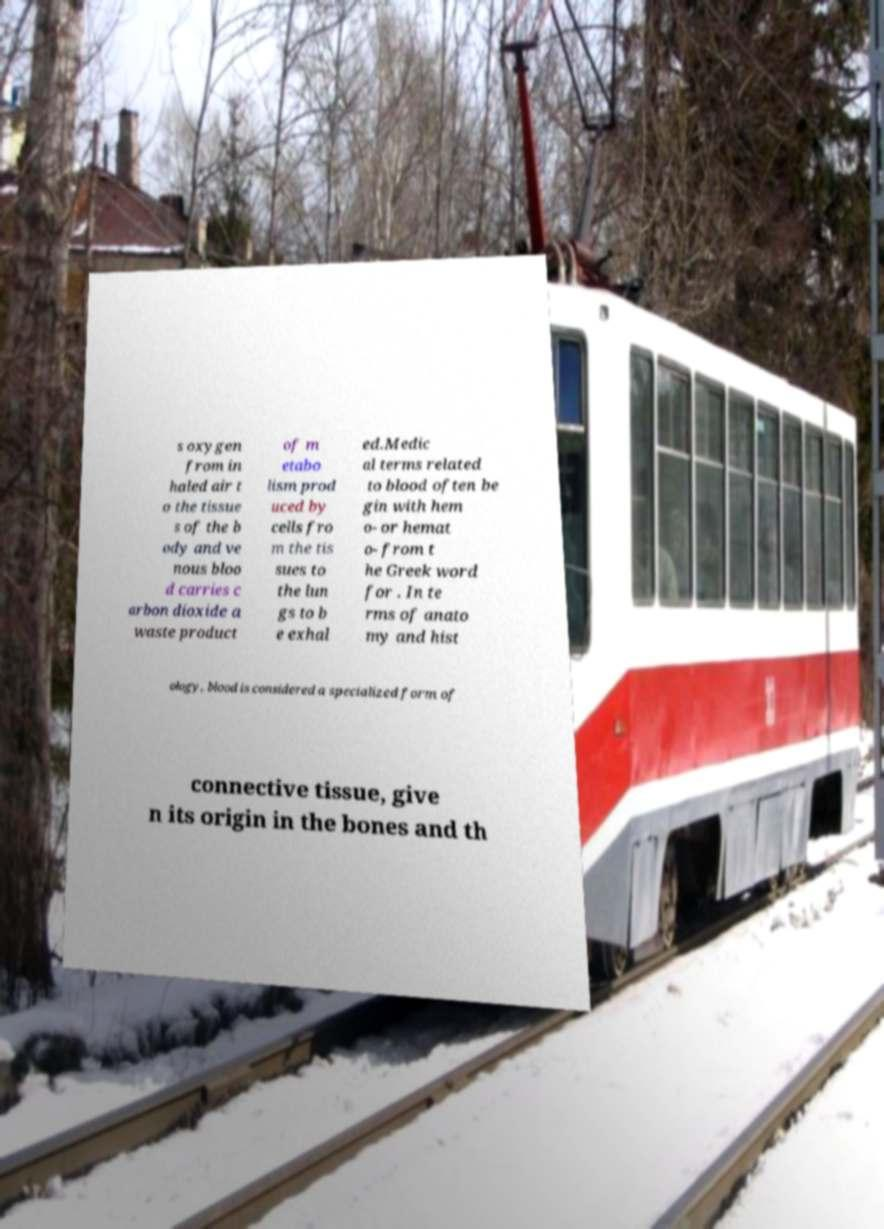For documentation purposes, I need the text within this image transcribed. Could you provide that? s oxygen from in haled air t o the tissue s of the b ody and ve nous bloo d carries c arbon dioxide a waste product of m etabo lism prod uced by cells fro m the tis sues to the lun gs to b e exhal ed.Medic al terms related to blood often be gin with hem o- or hemat o- from t he Greek word for . In te rms of anato my and hist ology, blood is considered a specialized form of connective tissue, give n its origin in the bones and th 